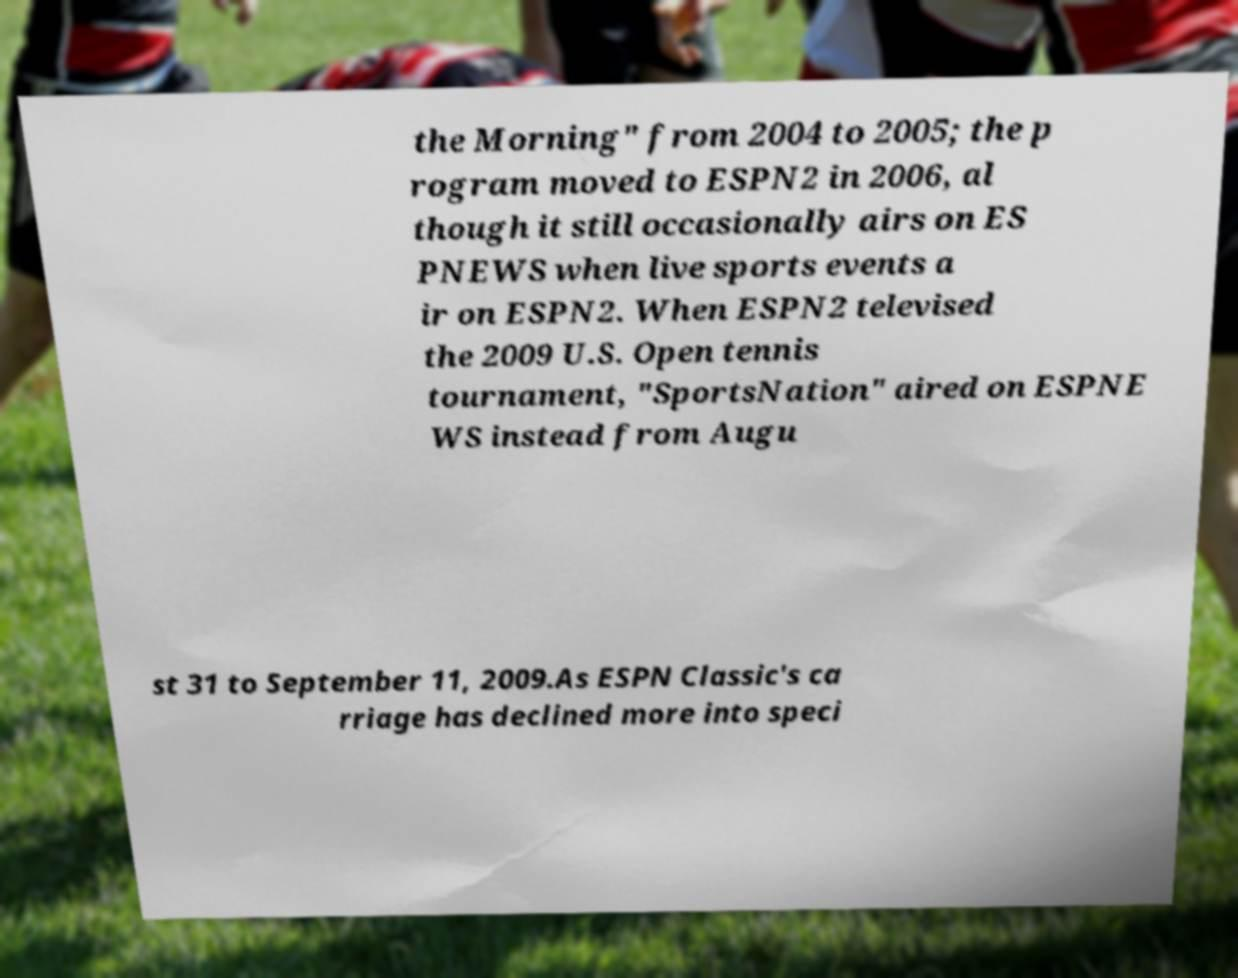Can you read and provide the text displayed in the image?This photo seems to have some interesting text. Can you extract and type it out for me? the Morning" from 2004 to 2005; the p rogram moved to ESPN2 in 2006, al though it still occasionally airs on ES PNEWS when live sports events a ir on ESPN2. When ESPN2 televised the 2009 U.S. Open tennis tournament, "SportsNation" aired on ESPNE WS instead from Augu st 31 to September 11, 2009.As ESPN Classic's ca rriage has declined more into speci 